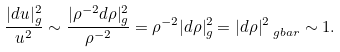Convert formula to latex. <formula><loc_0><loc_0><loc_500><loc_500>\frac { | d u | _ { g } ^ { 2 } } { u ^ { 2 } } \sim \frac { | \rho ^ { - 2 } d \rho | _ { g } ^ { 2 } } { \rho ^ { - 2 } } = \rho ^ { - 2 } | d \rho | _ { g } ^ { 2 } = | d \rho | _ { \ g b a r } ^ { 2 } \sim 1 .</formula> 